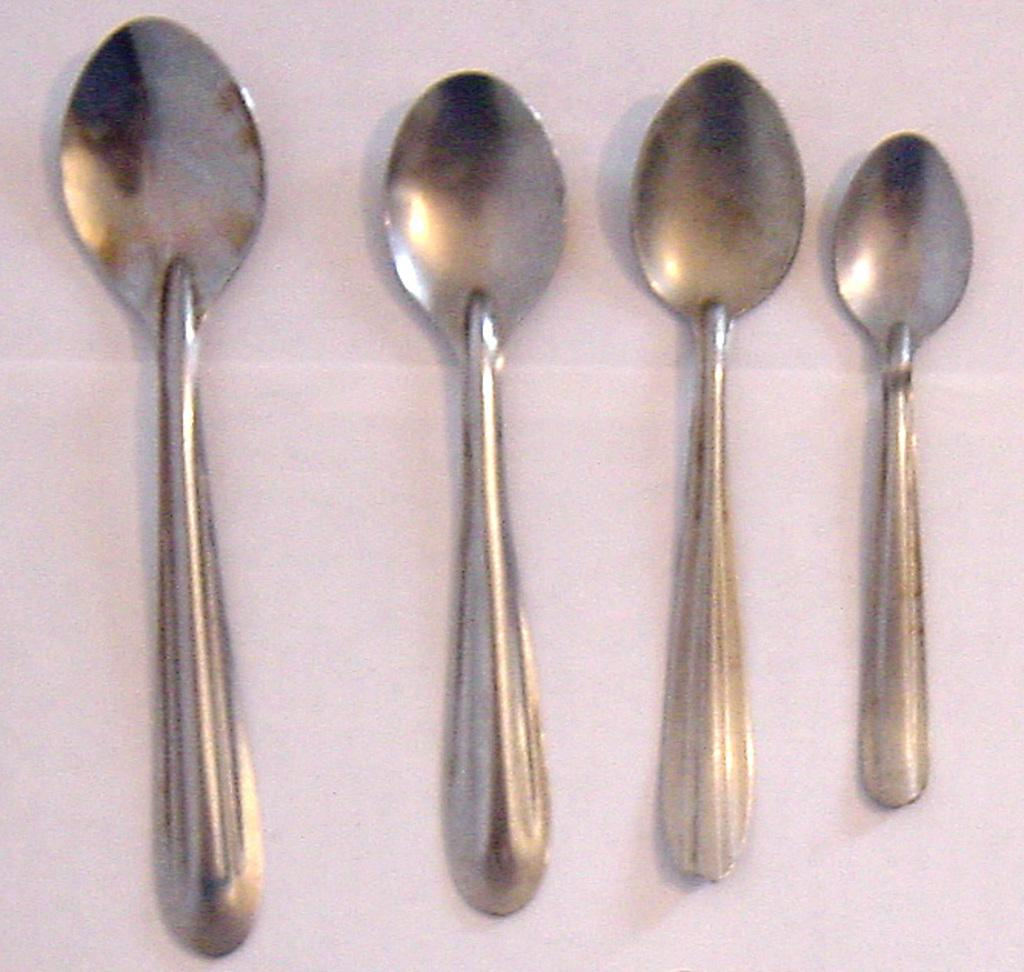How many spoons are present in the image? There are four spoons in the image. What can be observed about the arrangement of the spoons? The spoons are assembled by their sizes. What type of insect can be seen flying near the spoons in the image? There is no insect present in the image; it only features spoons arranged by size. 